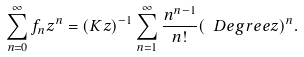Convert formula to latex. <formula><loc_0><loc_0><loc_500><loc_500>\sum _ { n = 0 } ^ { \infty } f _ { n } z ^ { n } = ( K z ) ^ { - 1 } \sum _ { n = 1 } ^ { \infty } \frac { n ^ { n - 1 } } { n ! } ( \ D e g r e e z ) ^ { n } .</formula> 